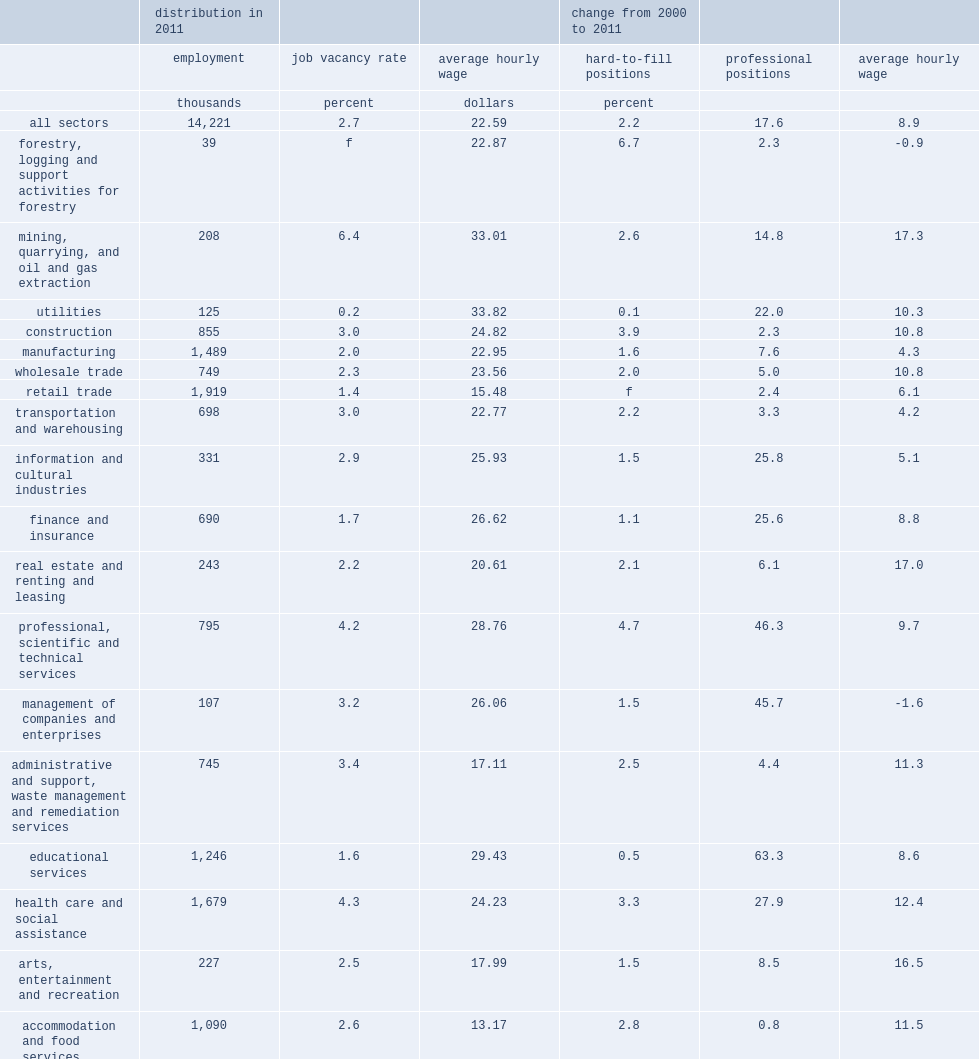Which sector posted the highest vacancy rate in december 2011? Mining, quarrying, and oil and gas extraction. Which sector posted the lowest vacancy rate in december 2011? Utilities. What were the percentages of average hourly wage increased in mining, quarrying, and oil and gas extraction and all sectors as a whole respectively? 17.3 8.9. 